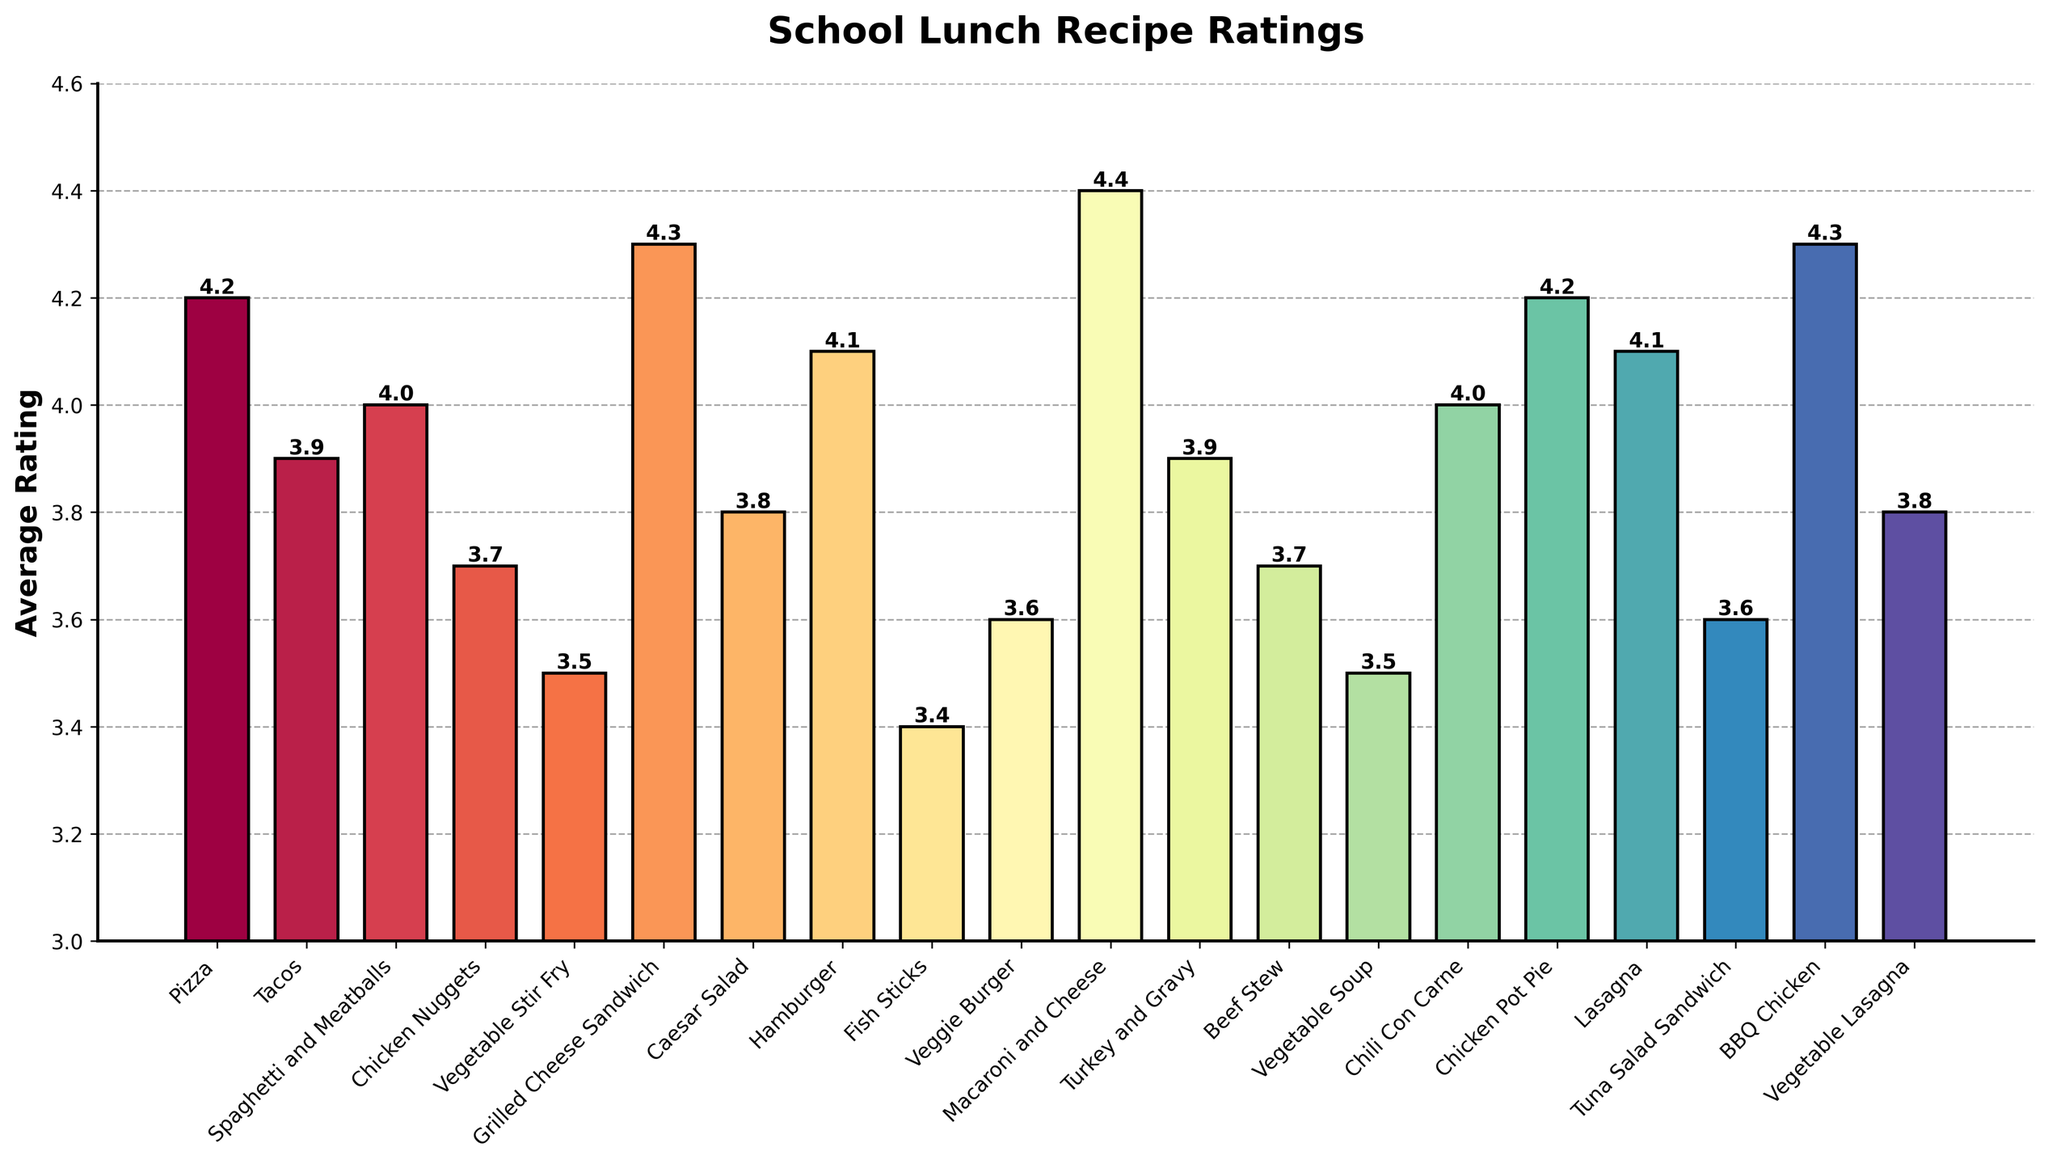Which food category has the highest average rating? To find the food category with the highest average rating, look at the bar that reaches the highest point on the y-axis. The bar for "Macaroni and Cheese" is the highest, so it has the highest average rating.
Answer: Macaroni and Cheese Which food category has a lower average rating: Caesar Salad or Vegetable Lasagna? Compare the heights of the bars for Caesar Salad and Vegetable Lasagna. The bar for Caesar Salad is slightly higher than the bar for Vegetable Lasagna, so Vegetable Lasagna has the lower average rating.
Answer: Vegetable Lasagna What is the average rating difference between the highest and lowest rated food categories? The highest rated is Macaroni and Cheese (4.4), and the lowest rated is Fish Sticks (3.4). Calculating the difference: 4.4 - 3.4 = 1.0.
Answer: 1.0 How many food categories have an average rating of 4.0 or higher? Count the number of bars that reach or exceed the 4.0 mark on the y-axis. Those are: Pizza, Spaghetti and Meatballs, Grilled Cheese Sandwich, Hamburger, Macaroni and Cheese, Chicken Pot Pie, Lasagna, and BBQ Chicken. This totals to 8 categories.
Answer: 8 Which two food categories have the closest average ratings? Look for bars with similar heights. The bars for Beef Stew and Chicken Nuggets appear very close to each other, both having an average rating of 3.7.
Answer: Beef Stew and Chicken Nuggets What is the combined average rating for Pizza, Tacos, and Chicken Nuggets? Add the average ratings of Pizza (4.2), Tacos (3.9), and Chicken Nuggets (3.7). So, 4.2 + 3.9 + 3.7 = 11.8.
Answer: 11.8 What is the average rating trend for the two lasagna-related categories? Look at the bars for Lasagna and Vegetable Lasagna. Lasagna has a higher average rating (4.1) compared to Vegetable Lasagna (3.8). So, there is a decreasing trend from Lasagna to Vegetable Lasagna.
Answer: Decreasing Which food category has an average rating that is exactly halfway between the ratings of Fish Sticks and BBQ Chicken? Calculate the midpoint between Fish Sticks (3.4) and BBQ Chicken (4.3), which is (3.4 + 4.3) / 2 = 3.85. The category closest to this value is Caesar Salad with an average rating of 3.8.
Answer: Caesar Salad Out of the following categories: Hamburger, Chili Con Carne, and Tuna Salad Sandwich, which has the highest average rating? Compare the average ratings: Hamburger (4.1), Chili Con Carne (4.0), and Tuna Salad Sandwich (3.6). Hamburger has the highest rating among these.
Answer: Hamburger 